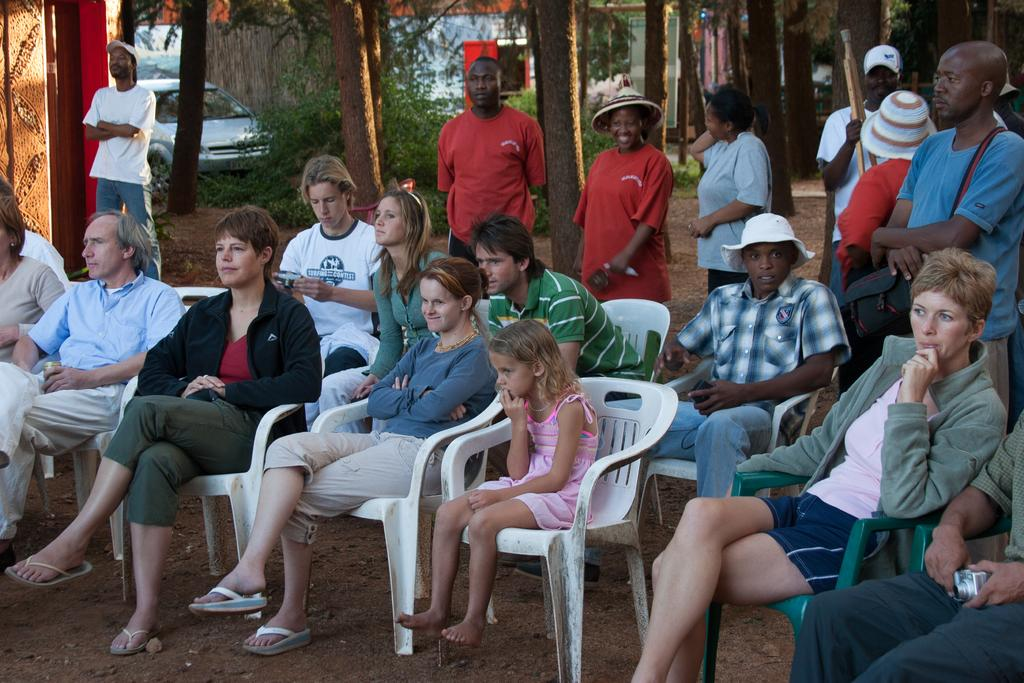What are the people in the image doing? There is a group of people sitting on chairs, and there are people standing. Can you describe the vehicles in the image? There is a car in the image. What can be seen in the background of the image? There are trees and a red object in the background. What type of jeans is the car wearing in the image? Cars do not wear jeans; they are inanimate objects. The question is not relevant to the image. 